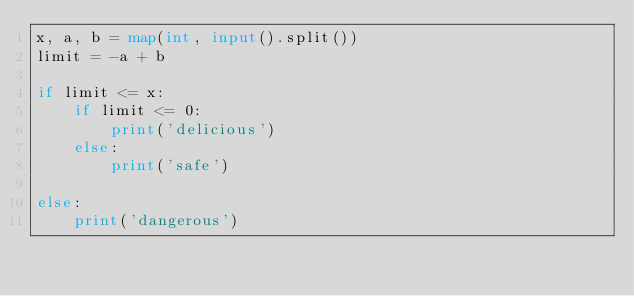Convert code to text. <code><loc_0><loc_0><loc_500><loc_500><_Python_>x, a, b = map(int, input().split())
limit = -a + b

if limit <= x:
    if limit <= 0:
        print('delicious')
    else:
        print('safe')

else:
    print('dangerous')</code> 